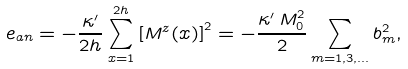<formula> <loc_0><loc_0><loc_500><loc_500>e _ { a n } = - \frac { \kappa ^ { \prime } } { 2 h } \sum _ { x = 1 } ^ { 2 h } \left [ M ^ { z } ( x ) \right ] ^ { 2 } = - \frac { \kappa ^ { \prime } \, M _ { 0 } ^ { 2 } } { 2 } \sum _ { m = 1 , 3 , \dots } b _ { m } ^ { 2 } ,</formula> 